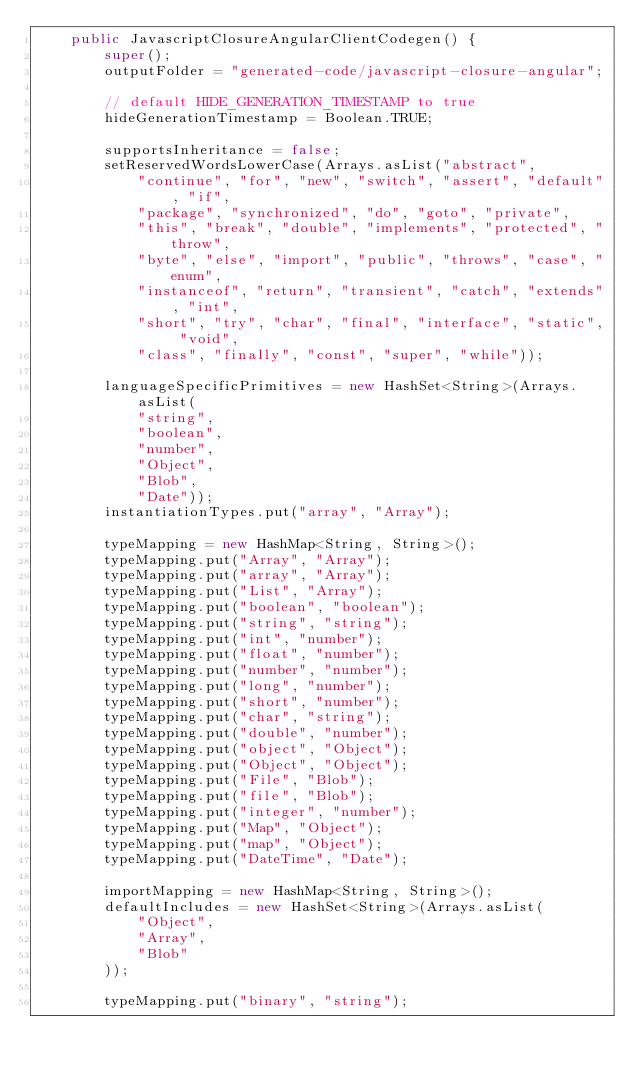<code> <loc_0><loc_0><loc_500><loc_500><_Java_>    public JavascriptClosureAngularClientCodegen() {
        super();
        outputFolder = "generated-code/javascript-closure-angular";

        // default HIDE_GENERATION_TIMESTAMP to true
        hideGenerationTimestamp = Boolean.TRUE;

        supportsInheritance = false;
        setReservedWordsLowerCase(Arrays.asList("abstract",
            "continue", "for", "new", "switch", "assert", "default", "if",
            "package", "synchronized", "do", "goto", "private",
            "this", "break", "double", "implements", "protected", "throw",
            "byte", "else", "import", "public", "throws", "case", "enum",
            "instanceof", "return", "transient", "catch", "extends", "int",
            "short", "try", "char", "final", "interface", "static", "void",
            "class", "finally", "const", "super", "while"));

        languageSpecificPrimitives = new HashSet<String>(Arrays.asList(
            "string",
            "boolean",
            "number",
            "Object",
            "Blob",
            "Date"));
        instantiationTypes.put("array", "Array");

        typeMapping = new HashMap<String, String>();
        typeMapping.put("Array", "Array");
        typeMapping.put("array", "Array");
        typeMapping.put("List", "Array");
        typeMapping.put("boolean", "boolean");
        typeMapping.put("string", "string");
        typeMapping.put("int", "number");
        typeMapping.put("float", "number");
        typeMapping.put("number", "number");
        typeMapping.put("long", "number");
        typeMapping.put("short", "number");
        typeMapping.put("char", "string");
        typeMapping.put("double", "number");
        typeMapping.put("object", "Object");
        typeMapping.put("Object", "Object");
        typeMapping.put("File", "Blob");
        typeMapping.put("file", "Blob");
        typeMapping.put("integer", "number");
        typeMapping.put("Map", "Object");
        typeMapping.put("map", "Object");
        typeMapping.put("DateTime", "Date");

        importMapping = new HashMap<String, String>();
        defaultIncludes = new HashSet<String>(Arrays.asList(
            "Object",
            "Array",
            "Blob"
        ));

        typeMapping.put("binary", "string");
</code> 